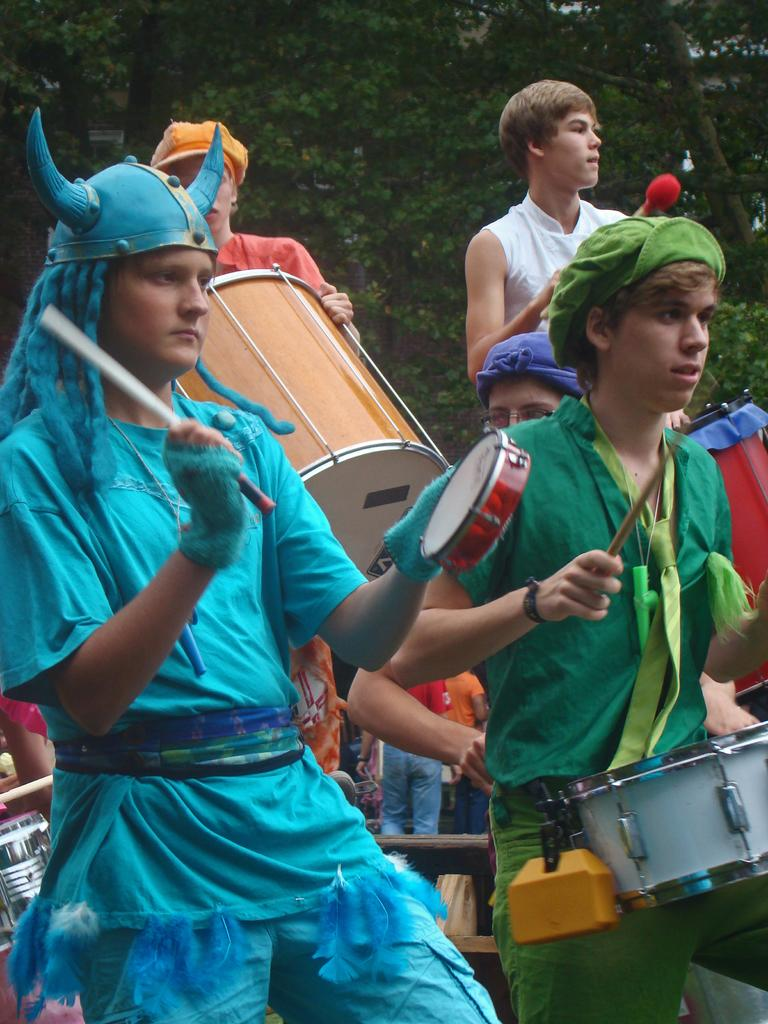What is the main subject of the image? The main subject of the image is a group of people. What are the people in the image doing? The people are standing and playing drums. What type of vegetation is visible in the image? There are trees visible in the image. Can you see any fog in the image? There is no fog visible in the image. What color are the toes of the people playing drums? The image does not show the toes of the people playing drums, so it cannot be determined from the picture. 